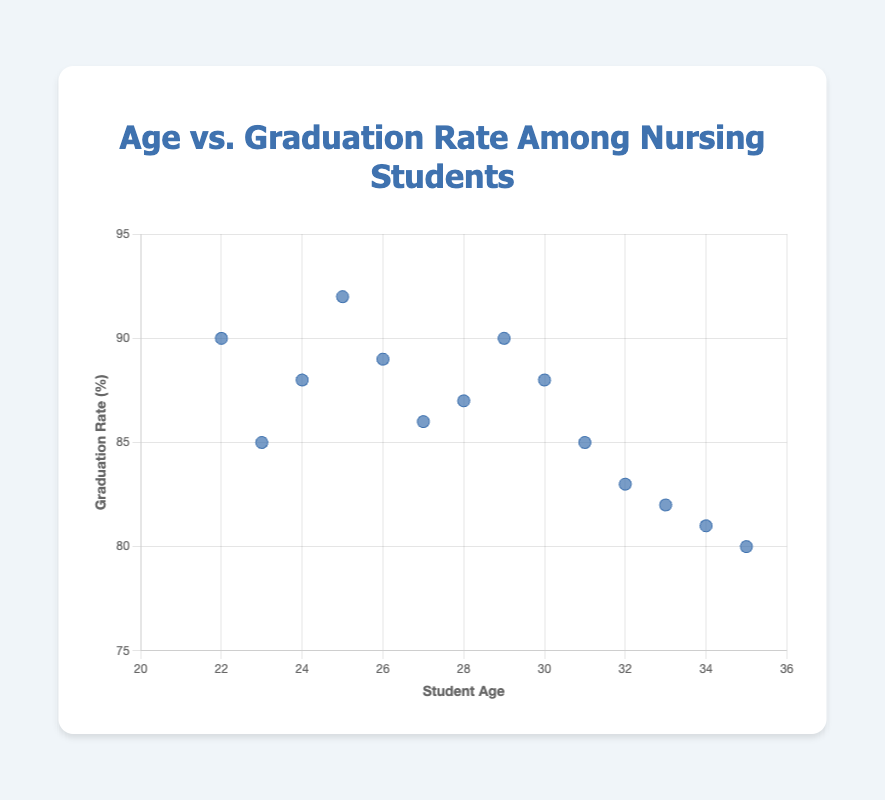What is the title of the figure? The title is clearly displayed at the top of the figure. It states "Age vs. Graduation Rate Among Nursing Students".
Answer: Age vs. Graduation Rate Among Nursing Students What is plotted on the x-axis? The label on the x-axis indicates it represents the age of the students.
Answer: Student Age What is the range of the graduation rates displayed in the figure? By observing the y-axis, the values range from 80% to 92%.
Answer: 80% to 92% What are the graduation rates for students aged 22 and 35? From the data points, the graduation rate for a 22-year-old is 90%, and for a 35-year-old is 80%.
Answer: 90% and 80% Which age group has the highest graduation rate? By looking at the data points, the highest graduation rate is observed at age 25 with 92%.
Answer: Age 25 Is there a clear trend between age and graduation rate? The data shows a general trend of a declining graduation rate as the age of the students increases.
Answer: Yes, a declining trend How many data points are in the scatter plot? Each point represents one student, corresponding directly to number of data entries. There are 14 data points.
Answer: 14 What is the average graduation rate for students aged 30 and above? Identify the graduation rates for ages 30 to 35 (88%, 85%, 83%, 82%, 81%, 80%). The sum is 499, divided by 6 yields approximately 83.2%.
Answer: 83.2% Compare the graduation rates of students aged 24 and 31. Which is higher? From the data, the graduation rate for a 24-year-old is 88%, and for a 31-year-old, it is 85%. Therefore, 24-year-old students have a higher rate.
Answer: Age 24 Does any age group have the same graduation rate? Observing the individual data points, ages 22 and 29 both have a graduation rate of 90%.
Answer: Yes, ages 22 and 29 